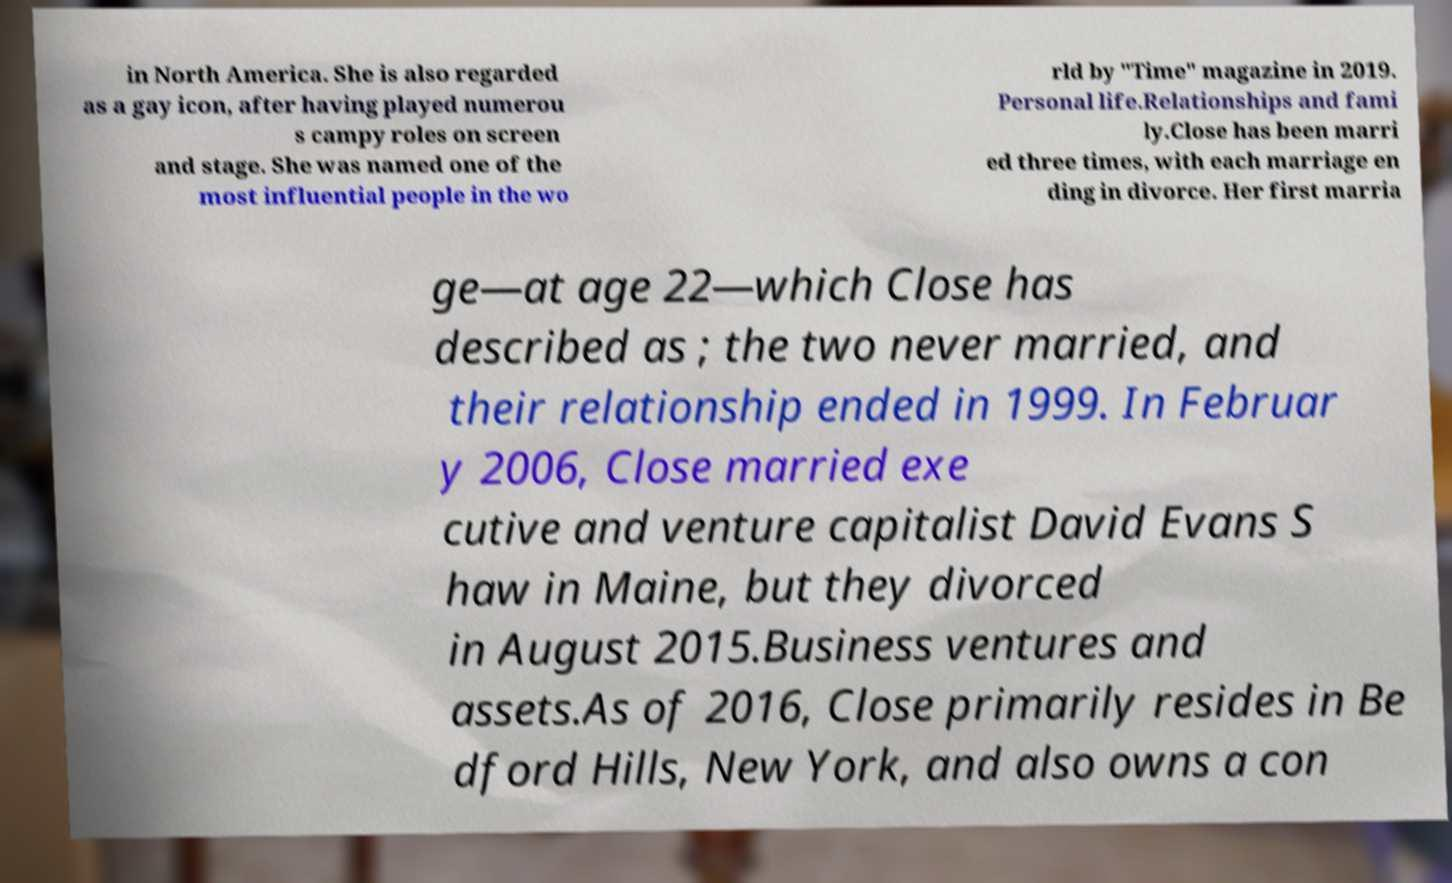Please read and relay the text visible in this image. What does it say? in North America. She is also regarded as a gay icon, after having played numerou s campy roles on screen and stage. She was named one of the most influential people in the wo rld by "Time" magazine in 2019. Personal life.Relationships and fami ly.Close has been marri ed three times, with each marriage en ding in divorce. Her first marria ge—at age 22—which Close has described as ; the two never married, and their relationship ended in 1999. In Februar y 2006, Close married exe cutive and venture capitalist David Evans S haw in Maine, but they divorced in August 2015.Business ventures and assets.As of 2016, Close primarily resides in Be dford Hills, New York, and also owns a con 